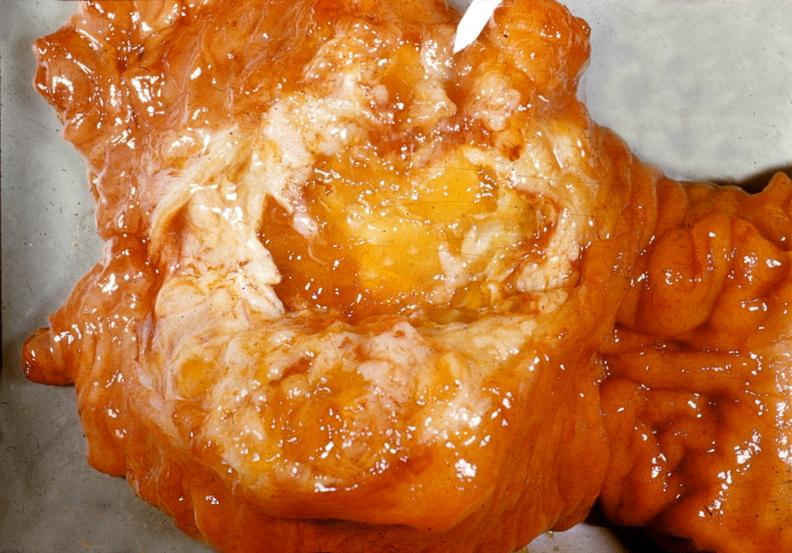what is present?
Answer the question using a single word or phrase. Pancreas 